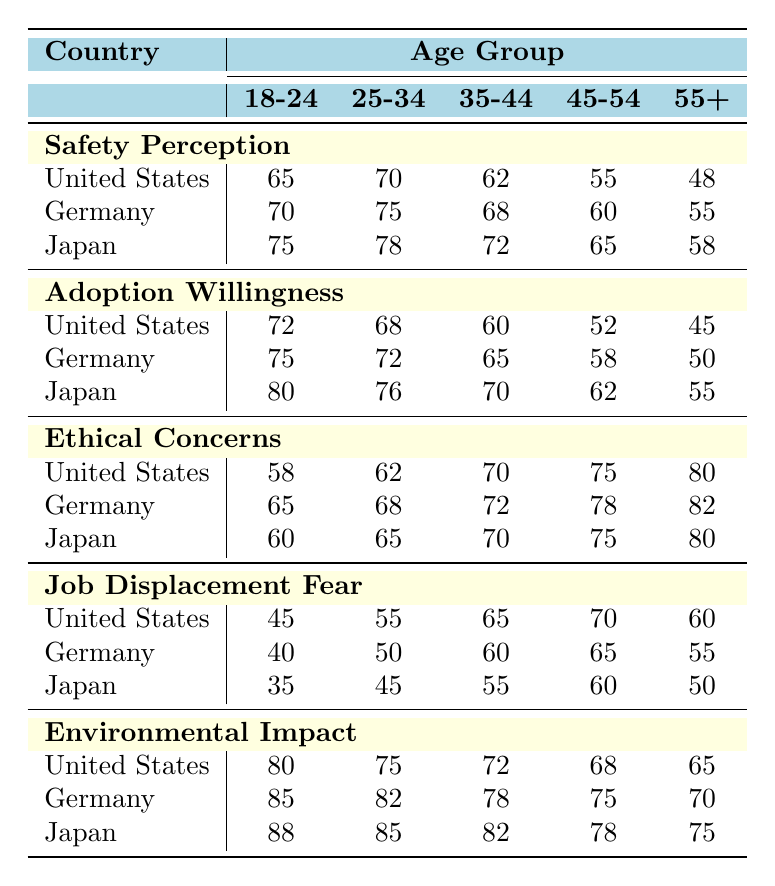What is the highest safety perception value recorded in the table? Upon reviewing the "Safety Perception" section, the values are 65, 70, and 75 for each age group and country. Among these, 75 is the highest, which corresponds to the age group 18-24 in Japan.
Answer: 75 Which age group in the United States has the lowest adoption willingness? Looking at the "Adoption Willingness" data for the United States, the values are 72, 68, 60, 52, and 45 across age groups 18-24, 25-34, 35-44, 45-54, and 55+, respectively. The lowest value is 45 for the 55+ age group.
Answer: 55+ Is the ethical concern higher among the 45-54 age group in Germany compared to the same age group in Japan? The table shows that for the 45-54 age group, the ethical concern is 78 in Germany and 75 in Japan. Therefore, the ethical concern is indeed higher in Germany than in Japan for this age group.
Answer: Yes What is the average environmental impact score for the age group 25-34 across all countries? To find the average environmental impact for the 25-34 age group, we will sum the values for the US (75), Germany (82), and Japan (76), totaling 233. Then divide by the number of countries, which is 3; thus, the average is 233/3 = 77.67.
Answer: 77.67 In which country do the youngest age group (18-24) exhibit the highest job displacement fear? The job displacement fear for the 18-24 age group is 45 in the US, 40 in Germany, and 35 in Japan. The highest value is 45, which is found in the United States.
Answer: United States What is the difference in safety perception between the oldest age group (55+) in the United States and that in Germany? For the 55+ age group, the safety perception in the US is 48, while in Germany it is 55. The difference is 55 - 48 = 7.
Answer: 7 